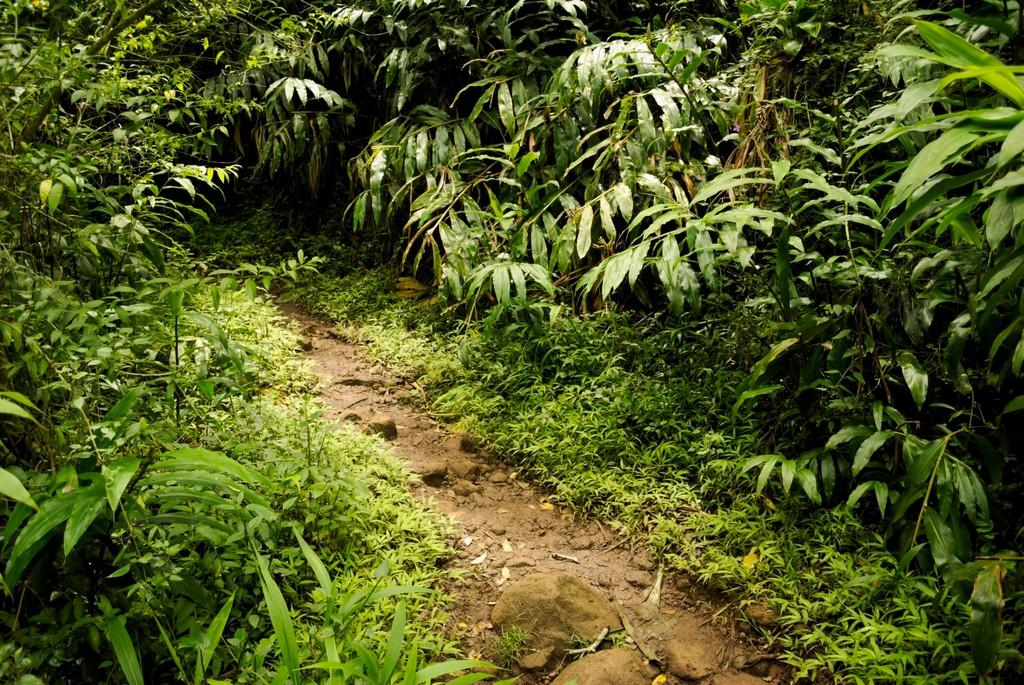What type of vegetation can be seen in the image? There are trees, plants, and grass in the image. What is present at the bottom of the image? There are stones at the bottom of the image. Where can green leaves be found in the image? Green leaves can be found on the left side of the image. How many shoes are hanging from the trees in the image? There are no shoes present in the image; it features trees, plants, grass, and stones. 